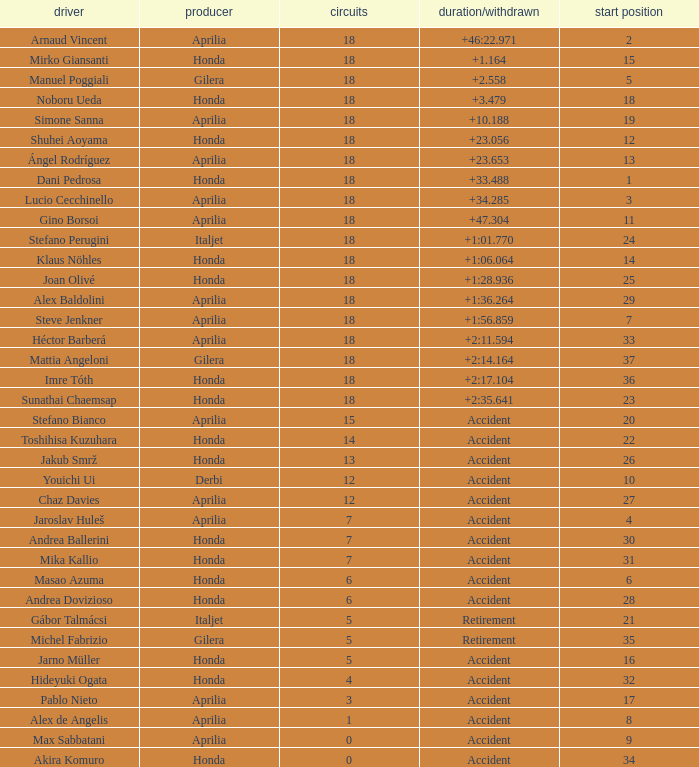Who is the rider with less than 15 laps, more than 32 grids, and an accident time/retired? Akira Komuro. 